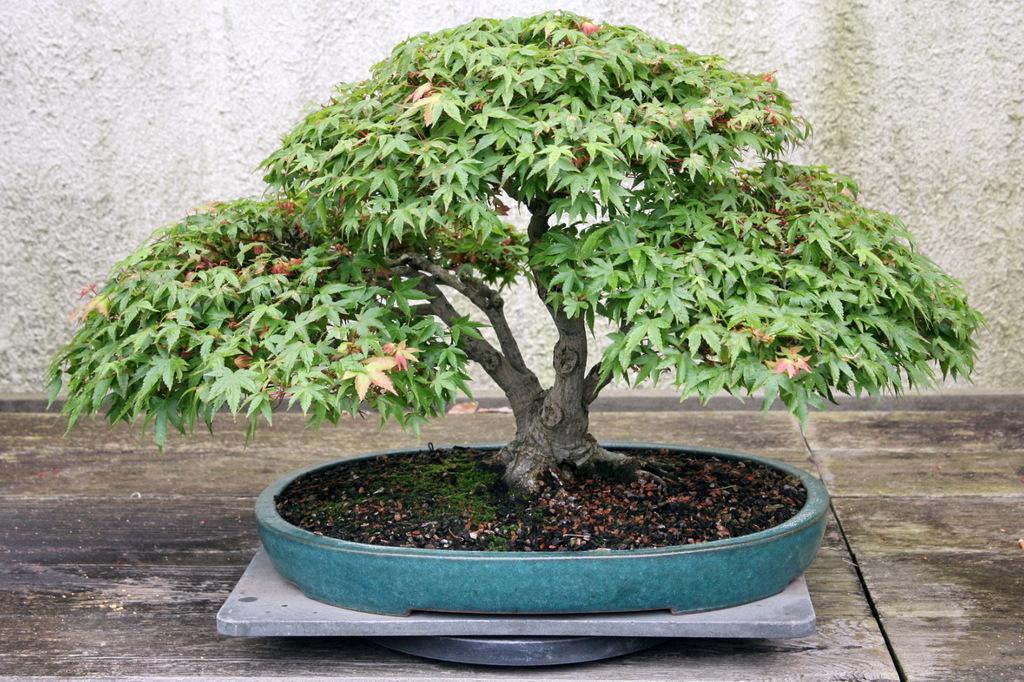How would you summarize this image in a sentence or two? In this picture we can see a tree in a flower pot with soil and this flower pot is placed on a metal sheet and this metal sheet is on a floor and in background we can see a. wall 